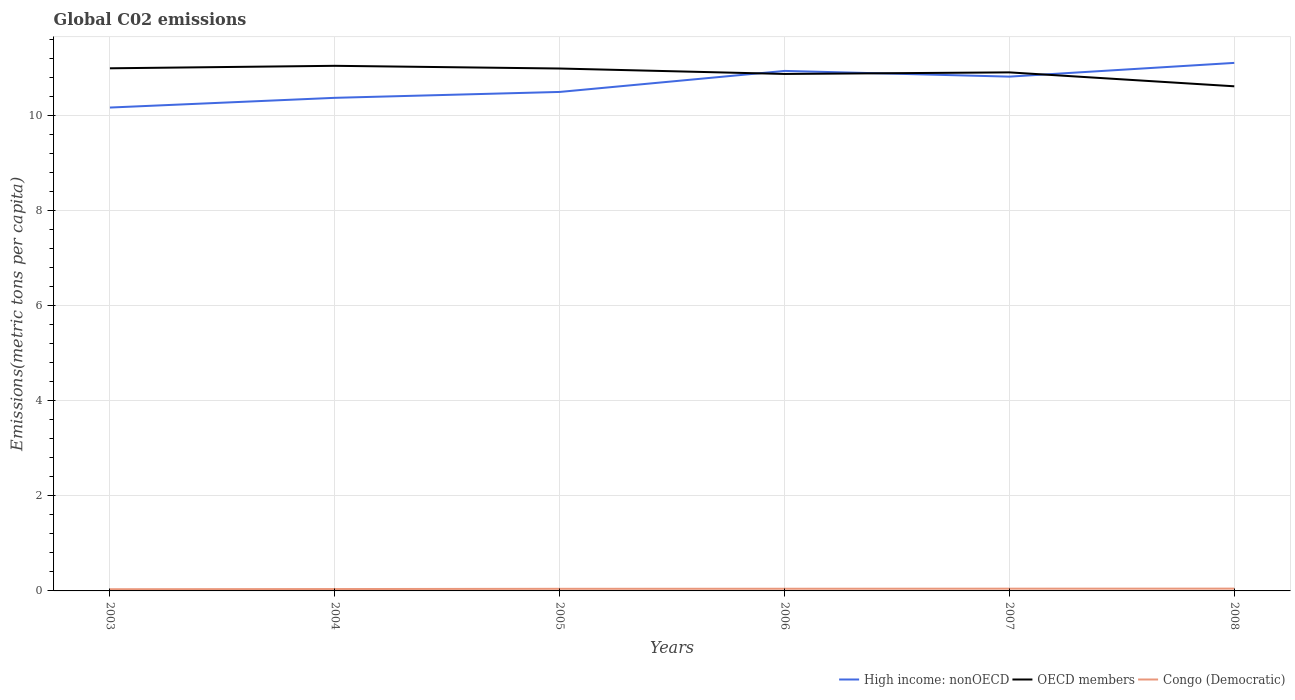Does the line corresponding to OECD members intersect with the line corresponding to High income: nonOECD?
Your answer should be compact. Yes. Across all years, what is the maximum amount of CO2 emitted in in High income: nonOECD?
Offer a very short reply. 10.17. What is the total amount of CO2 emitted in in OECD members in the graph?
Keep it short and to the point. 0.14. What is the difference between the highest and the second highest amount of CO2 emitted in in High income: nonOECD?
Your answer should be very brief. 0.94. Is the amount of CO2 emitted in in Congo (Democratic) strictly greater than the amount of CO2 emitted in in High income: nonOECD over the years?
Offer a terse response. Yes. How many lines are there?
Make the answer very short. 3. Are the values on the major ticks of Y-axis written in scientific E-notation?
Provide a succinct answer. No. Does the graph contain any zero values?
Your answer should be compact. No. Does the graph contain grids?
Ensure brevity in your answer.  Yes. Where does the legend appear in the graph?
Keep it short and to the point. Bottom right. What is the title of the graph?
Ensure brevity in your answer.  Global C02 emissions. Does "Korea (Democratic)" appear as one of the legend labels in the graph?
Ensure brevity in your answer.  No. What is the label or title of the Y-axis?
Make the answer very short. Emissions(metric tons per capita). What is the Emissions(metric tons per capita) of High income: nonOECD in 2003?
Your answer should be very brief. 10.17. What is the Emissions(metric tons per capita) of OECD members in 2003?
Provide a succinct answer. 11. What is the Emissions(metric tons per capita) in Congo (Democratic) in 2003?
Keep it short and to the point. 0.04. What is the Emissions(metric tons per capita) in High income: nonOECD in 2004?
Make the answer very short. 10.37. What is the Emissions(metric tons per capita) in OECD members in 2004?
Your answer should be very brief. 11.05. What is the Emissions(metric tons per capita) in Congo (Democratic) in 2004?
Provide a short and direct response. 0.04. What is the Emissions(metric tons per capita) of High income: nonOECD in 2005?
Ensure brevity in your answer.  10.5. What is the Emissions(metric tons per capita) of OECD members in 2005?
Your answer should be very brief. 10.99. What is the Emissions(metric tons per capita) of Congo (Democratic) in 2005?
Provide a succinct answer. 0.04. What is the Emissions(metric tons per capita) in High income: nonOECD in 2006?
Your answer should be compact. 10.94. What is the Emissions(metric tons per capita) in OECD members in 2006?
Offer a very short reply. 10.88. What is the Emissions(metric tons per capita) of Congo (Democratic) in 2006?
Your answer should be compact. 0.05. What is the Emissions(metric tons per capita) of High income: nonOECD in 2007?
Provide a short and direct response. 10.82. What is the Emissions(metric tons per capita) of OECD members in 2007?
Give a very brief answer. 10.91. What is the Emissions(metric tons per capita) in Congo (Democratic) in 2007?
Your answer should be compact. 0.05. What is the Emissions(metric tons per capita) in High income: nonOECD in 2008?
Make the answer very short. 11.11. What is the Emissions(metric tons per capita) in OECD members in 2008?
Provide a succinct answer. 10.62. What is the Emissions(metric tons per capita) in Congo (Democratic) in 2008?
Your response must be concise. 0.05. Across all years, what is the maximum Emissions(metric tons per capita) in High income: nonOECD?
Provide a short and direct response. 11.11. Across all years, what is the maximum Emissions(metric tons per capita) in OECD members?
Ensure brevity in your answer.  11.05. Across all years, what is the maximum Emissions(metric tons per capita) in Congo (Democratic)?
Offer a terse response. 0.05. Across all years, what is the minimum Emissions(metric tons per capita) of High income: nonOECD?
Your answer should be very brief. 10.17. Across all years, what is the minimum Emissions(metric tons per capita) in OECD members?
Make the answer very short. 10.62. Across all years, what is the minimum Emissions(metric tons per capita) in Congo (Democratic)?
Make the answer very short. 0.04. What is the total Emissions(metric tons per capita) in High income: nonOECD in the graph?
Provide a short and direct response. 63.92. What is the total Emissions(metric tons per capita) in OECD members in the graph?
Make the answer very short. 65.44. What is the total Emissions(metric tons per capita) of Congo (Democratic) in the graph?
Provide a succinct answer. 0.26. What is the difference between the Emissions(metric tons per capita) in High income: nonOECD in 2003 and that in 2004?
Provide a short and direct response. -0.2. What is the difference between the Emissions(metric tons per capita) of OECD members in 2003 and that in 2004?
Offer a very short reply. -0.05. What is the difference between the Emissions(metric tons per capita) of Congo (Democratic) in 2003 and that in 2004?
Give a very brief answer. -0. What is the difference between the Emissions(metric tons per capita) of High income: nonOECD in 2003 and that in 2005?
Provide a succinct answer. -0.33. What is the difference between the Emissions(metric tons per capita) of OECD members in 2003 and that in 2005?
Your answer should be compact. 0. What is the difference between the Emissions(metric tons per capita) in Congo (Democratic) in 2003 and that in 2005?
Your response must be concise. -0.01. What is the difference between the Emissions(metric tons per capita) of High income: nonOECD in 2003 and that in 2006?
Make the answer very short. -0.77. What is the difference between the Emissions(metric tons per capita) in OECD members in 2003 and that in 2006?
Your answer should be compact. 0.12. What is the difference between the Emissions(metric tons per capita) of Congo (Democratic) in 2003 and that in 2006?
Keep it short and to the point. -0.01. What is the difference between the Emissions(metric tons per capita) in High income: nonOECD in 2003 and that in 2007?
Give a very brief answer. -0.65. What is the difference between the Emissions(metric tons per capita) of OECD members in 2003 and that in 2007?
Your answer should be compact. 0.09. What is the difference between the Emissions(metric tons per capita) in Congo (Democratic) in 2003 and that in 2007?
Your response must be concise. -0.01. What is the difference between the Emissions(metric tons per capita) of High income: nonOECD in 2003 and that in 2008?
Provide a succinct answer. -0.94. What is the difference between the Emissions(metric tons per capita) in OECD members in 2003 and that in 2008?
Offer a terse response. 0.38. What is the difference between the Emissions(metric tons per capita) of Congo (Democratic) in 2003 and that in 2008?
Provide a short and direct response. -0.01. What is the difference between the Emissions(metric tons per capita) in High income: nonOECD in 2004 and that in 2005?
Your answer should be very brief. -0.12. What is the difference between the Emissions(metric tons per capita) of OECD members in 2004 and that in 2005?
Make the answer very short. 0.06. What is the difference between the Emissions(metric tons per capita) of Congo (Democratic) in 2004 and that in 2005?
Make the answer very short. -0.01. What is the difference between the Emissions(metric tons per capita) in High income: nonOECD in 2004 and that in 2006?
Your answer should be very brief. -0.57. What is the difference between the Emissions(metric tons per capita) in OECD members in 2004 and that in 2006?
Your response must be concise. 0.17. What is the difference between the Emissions(metric tons per capita) in Congo (Democratic) in 2004 and that in 2006?
Keep it short and to the point. -0.01. What is the difference between the Emissions(metric tons per capita) of High income: nonOECD in 2004 and that in 2007?
Your answer should be very brief. -0.45. What is the difference between the Emissions(metric tons per capita) in OECD members in 2004 and that in 2007?
Your answer should be very brief. 0.14. What is the difference between the Emissions(metric tons per capita) of Congo (Democratic) in 2004 and that in 2007?
Make the answer very short. -0.01. What is the difference between the Emissions(metric tons per capita) of High income: nonOECD in 2004 and that in 2008?
Provide a succinct answer. -0.73. What is the difference between the Emissions(metric tons per capita) of OECD members in 2004 and that in 2008?
Your answer should be very brief. 0.43. What is the difference between the Emissions(metric tons per capita) in Congo (Democratic) in 2004 and that in 2008?
Your response must be concise. -0.01. What is the difference between the Emissions(metric tons per capita) of High income: nonOECD in 2005 and that in 2006?
Your response must be concise. -0.44. What is the difference between the Emissions(metric tons per capita) of OECD members in 2005 and that in 2006?
Provide a succinct answer. 0.11. What is the difference between the Emissions(metric tons per capita) of Congo (Democratic) in 2005 and that in 2006?
Give a very brief answer. -0. What is the difference between the Emissions(metric tons per capita) in High income: nonOECD in 2005 and that in 2007?
Your answer should be compact. -0.32. What is the difference between the Emissions(metric tons per capita) in OECD members in 2005 and that in 2007?
Provide a succinct answer. 0.08. What is the difference between the Emissions(metric tons per capita) of Congo (Democratic) in 2005 and that in 2007?
Ensure brevity in your answer.  -0. What is the difference between the Emissions(metric tons per capita) in High income: nonOECD in 2005 and that in 2008?
Provide a short and direct response. -0.61. What is the difference between the Emissions(metric tons per capita) of OECD members in 2005 and that in 2008?
Keep it short and to the point. 0.37. What is the difference between the Emissions(metric tons per capita) in Congo (Democratic) in 2005 and that in 2008?
Provide a succinct answer. -0. What is the difference between the Emissions(metric tons per capita) in High income: nonOECD in 2006 and that in 2007?
Offer a terse response. 0.12. What is the difference between the Emissions(metric tons per capita) of OECD members in 2006 and that in 2007?
Provide a succinct answer. -0.03. What is the difference between the Emissions(metric tons per capita) in Congo (Democratic) in 2006 and that in 2007?
Ensure brevity in your answer.  -0. What is the difference between the Emissions(metric tons per capita) in High income: nonOECD in 2006 and that in 2008?
Make the answer very short. -0.17. What is the difference between the Emissions(metric tons per capita) in OECD members in 2006 and that in 2008?
Your answer should be very brief. 0.26. What is the difference between the Emissions(metric tons per capita) in Congo (Democratic) in 2006 and that in 2008?
Your response must be concise. -0. What is the difference between the Emissions(metric tons per capita) in High income: nonOECD in 2007 and that in 2008?
Your answer should be very brief. -0.29. What is the difference between the Emissions(metric tons per capita) in OECD members in 2007 and that in 2008?
Your answer should be very brief. 0.29. What is the difference between the Emissions(metric tons per capita) in Congo (Democratic) in 2007 and that in 2008?
Offer a terse response. -0. What is the difference between the Emissions(metric tons per capita) in High income: nonOECD in 2003 and the Emissions(metric tons per capita) in OECD members in 2004?
Provide a succinct answer. -0.88. What is the difference between the Emissions(metric tons per capita) in High income: nonOECD in 2003 and the Emissions(metric tons per capita) in Congo (Democratic) in 2004?
Your response must be concise. 10.13. What is the difference between the Emissions(metric tons per capita) in OECD members in 2003 and the Emissions(metric tons per capita) in Congo (Democratic) in 2004?
Make the answer very short. 10.96. What is the difference between the Emissions(metric tons per capita) of High income: nonOECD in 2003 and the Emissions(metric tons per capita) of OECD members in 2005?
Provide a short and direct response. -0.82. What is the difference between the Emissions(metric tons per capita) in High income: nonOECD in 2003 and the Emissions(metric tons per capita) in Congo (Democratic) in 2005?
Offer a very short reply. 10.13. What is the difference between the Emissions(metric tons per capita) of OECD members in 2003 and the Emissions(metric tons per capita) of Congo (Democratic) in 2005?
Keep it short and to the point. 10.95. What is the difference between the Emissions(metric tons per capita) in High income: nonOECD in 2003 and the Emissions(metric tons per capita) in OECD members in 2006?
Ensure brevity in your answer.  -0.71. What is the difference between the Emissions(metric tons per capita) in High income: nonOECD in 2003 and the Emissions(metric tons per capita) in Congo (Democratic) in 2006?
Give a very brief answer. 10.12. What is the difference between the Emissions(metric tons per capita) in OECD members in 2003 and the Emissions(metric tons per capita) in Congo (Democratic) in 2006?
Offer a terse response. 10.95. What is the difference between the Emissions(metric tons per capita) in High income: nonOECD in 2003 and the Emissions(metric tons per capita) in OECD members in 2007?
Keep it short and to the point. -0.74. What is the difference between the Emissions(metric tons per capita) of High income: nonOECD in 2003 and the Emissions(metric tons per capita) of Congo (Democratic) in 2007?
Provide a succinct answer. 10.12. What is the difference between the Emissions(metric tons per capita) in OECD members in 2003 and the Emissions(metric tons per capita) in Congo (Democratic) in 2007?
Ensure brevity in your answer.  10.95. What is the difference between the Emissions(metric tons per capita) in High income: nonOECD in 2003 and the Emissions(metric tons per capita) in OECD members in 2008?
Give a very brief answer. -0.45. What is the difference between the Emissions(metric tons per capita) in High income: nonOECD in 2003 and the Emissions(metric tons per capita) in Congo (Democratic) in 2008?
Provide a short and direct response. 10.12. What is the difference between the Emissions(metric tons per capita) in OECD members in 2003 and the Emissions(metric tons per capita) in Congo (Democratic) in 2008?
Keep it short and to the point. 10.95. What is the difference between the Emissions(metric tons per capita) of High income: nonOECD in 2004 and the Emissions(metric tons per capita) of OECD members in 2005?
Ensure brevity in your answer.  -0.62. What is the difference between the Emissions(metric tons per capita) of High income: nonOECD in 2004 and the Emissions(metric tons per capita) of Congo (Democratic) in 2005?
Your answer should be very brief. 10.33. What is the difference between the Emissions(metric tons per capita) of OECD members in 2004 and the Emissions(metric tons per capita) of Congo (Democratic) in 2005?
Give a very brief answer. 11. What is the difference between the Emissions(metric tons per capita) of High income: nonOECD in 2004 and the Emissions(metric tons per capita) of OECD members in 2006?
Offer a terse response. -0.5. What is the difference between the Emissions(metric tons per capita) in High income: nonOECD in 2004 and the Emissions(metric tons per capita) in Congo (Democratic) in 2006?
Provide a succinct answer. 10.33. What is the difference between the Emissions(metric tons per capita) of OECD members in 2004 and the Emissions(metric tons per capita) of Congo (Democratic) in 2006?
Your answer should be very brief. 11. What is the difference between the Emissions(metric tons per capita) of High income: nonOECD in 2004 and the Emissions(metric tons per capita) of OECD members in 2007?
Your answer should be very brief. -0.54. What is the difference between the Emissions(metric tons per capita) of High income: nonOECD in 2004 and the Emissions(metric tons per capita) of Congo (Democratic) in 2007?
Keep it short and to the point. 10.33. What is the difference between the Emissions(metric tons per capita) in OECD members in 2004 and the Emissions(metric tons per capita) in Congo (Democratic) in 2007?
Your answer should be very brief. 11. What is the difference between the Emissions(metric tons per capita) of High income: nonOECD in 2004 and the Emissions(metric tons per capita) of OECD members in 2008?
Offer a terse response. -0.24. What is the difference between the Emissions(metric tons per capita) in High income: nonOECD in 2004 and the Emissions(metric tons per capita) in Congo (Democratic) in 2008?
Offer a very short reply. 10.33. What is the difference between the Emissions(metric tons per capita) in High income: nonOECD in 2005 and the Emissions(metric tons per capita) in OECD members in 2006?
Ensure brevity in your answer.  -0.38. What is the difference between the Emissions(metric tons per capita) of High income: nonOECD in 2005 and the Emissions(metric tons per capita) of Congo (Democratic) in 2006?
Your response must be concise. 10.45. What is the difference between the Emissions(metric tons per capita) of OECD members in 2005 and the Emissions(metric tons per capita) of Congo (Democratic) in 2006?
Your answer should be compact. 10.95. What is the difference between the Emissions(metric tons per capita) in High income: nonOECD in 2005 and the Emissions(metric tons per capita) in OECD members in 2007?
Offer a very short reply. -0.41. What is the difference between the Emissions(metric tons per capita) in High income: nonOECD in 2005 and the Emissions(metric tons per capita) in Congo (Democratic) in 2007?
Keep it short and to the point. 10.45. What is the difference between the Emissions(metric tons per capita) of OECD members in 2005 and the Emissions(metric tons per capita) of Congo (Democratic) in 2007?
Provide a short and direct response. 10.94. What is the difference between the Emissions(metric tons per capita) of High income: nonOECD in 2005 and the Emissions(metric tons per capita) of OECD members in 2008?
Your answer should be compact. -0.12. What is the difference between the Emissions(metric tons per capita) in High income: nonOECD in 2005 and the Emissions(metric tons per capita) in Congo (Democratic) in 2008?
Keep it short and to the point. 10.45. What is the difference between the Emissions(metric tons per capita) of OECD members in 2005 and the Emissions(metric tons per capita) of Congo (Democratic) in 2008?
Offer a terse response. 10.94. What is the difference between the Emissions(metric tons per capita) of High income: nonOECD in 2006 and the Emissions(metric tons per capita) of OECD members in 2007?
Your answer should be compact. 0.03. What is the difference between the Emissions(metric tons per capita) of High income: nonOECD in 2006 and the Emissions(metric tons per capita) of Congo (Democratic) in 2007?
Offer a very short reply. 10.89. What is the difference between the Emissions(metric tons per capita) of OECD members in 2006 and the Emissions(metric tons per capita) of Congo (Democratic) in 2007?
Give a very brief answer. 10.83. What is the difference between the Emissions(metric tons per capita) of High income: nonOECD in 2006 and the Emissions(metric tons per capita) of OECD members in 2008?
Your answer should be compact. 0.32. What is the difference between the Emissions(metric tons per capita) in High income: nonOECD in 2006 and the Emissions(metric tons per capita) in Congo (Democratic) in 2008?
Provide a short and direct response. 10.89. What is the difference between the Emissions(metric tons per capita) in OECD members in 2006 and the Emissions(metric tons per capita) in Congo (Democratic) in 2008?
Ensure brevity in your answer.  10.83. What is the difference between the Emissions(metric tons per capita) of High income: nonOECD in 2007 and the Emissions(metric tons per capita) of OECD members in 2008?
Provide a short and direct response. 0.2. What is the difference between the Emissions(metric tons per capita) in High income: nonOECD in 2007 and the Emissions(metric tons per capita) in Congo (Democratic) in 2008?
Your answer should be compact. 10.77. What is the difference between the Emissions(metric tons per capita) of OECD members in 2007 and the Emissions(metric tons per capita) of Congo (Democratic) in 2008?
Provide a short and direct response. 10.86. What is the average Emissions(metric tons per capita) of High income: nonOECD per year?
Keep it short and to the point. 10.65. What is the average Emissions(metric tons per capita) of OECD members per year?
Your answer should be very brief. 10.91. What is the average Emissions(metric tons per capita) in Congo (Democratic) per year?
Offer a very short reply. 0.04. In the year 2003, what is the difference between the Emissions(metric tons per capita) of High income: nonOECD and Emissions(metric tons per capita) of OECD members?
Your response must be concise. -0.83. In the year 2003, what is the difference between the Emissions(metric tons per capita) in High income: nonOECD and Emissions(metric tons per capita) in Congo (Democratic)?
Keep it short and to the point. 10.13. In the year 2003, what is the difference between the Emissions(metric tons per capita) of OECD members and Emissions(metric tons per capita) of Congo (Democratic)?
Your answer should be compact. 10.96. In the year 2004, what is the difference between the Emissions(metric tons per capita) of High income: nonOECD and Emissions(metric tons per capita) of OECD members?
Your answer should be compact. -0.67. In the year 2004, what is the difference between the Emissions(metric tons per capita) of High income: nonOECD and Emissions(metric tons per capita) of Congo (Democratic)?
Ensure brevity in your answer.  10.34. In the year 2004, what is the difference between the Emissions(metric tons per capita) of OECD members and Emissions(metric tons per capita) of Congo (Democratic)?
Ensure brevity in your answer.  11.01. In the year 2005, what is the difference between the Emissions(metric tons per capita) of High income: nonOECD and Emissions(metric tons per capita) of OECD members?
Your answer should be very brief. -0.49. In the year 2005, what is the difference between the Emissions(metric tons per capita) of High income: nonOECD and Emissions(metric tons per capita) of Congo (Democratic)?
Your response must be concise. 10.45. In the year 2005, what is the difference between the Emissions(metric tons per capita) in OECD members and Emissions(metric tons per capita) in Congo (Democratic)?
Keep it short and to the point. 10.95. In the year 2006, what is the difference between the Emissions(metric tons per capita) of High income: nonOECD and Emissions(metric tons per capita) of OECD members?
Provide a succinct answer. 0.06. In the year 2006, what is the difference between the Emissions(metric tons per capita) in High income: nonOECD and Emissions(metric tons per capita) in Congo (Democratic)?
Give a very brief answer. 10.9. In the year 2006, what is the difference between the Emissions(metric tons per capita) of OECD members and Emissions(metric tons per capita) of Congo (Democratic)?
Offer a very short reply. 10.83. In the year 2007, what is the difference between the Emissions(metric tons per capita) of High income: nonOECD and Emissions(metric tons per capita) of OECD members?
Offer a very short reply. -0.09. In the year 2007, what is the difference between the Emissions(metric tons per capita) of High income: nonOECD and Emissions(metric tons per capita) of Congo (Democratic)?
Provide a short and direct response. 10.77. In the year 2007, what is the difference between the Emissions(metric tons per capita) of OECD members and Emissions(metric tons per capita) of Congo (Democratic)?
Make the answer very short. 10.86. In the year 2008, what is the difference between the Emissions(metric tons per capita) in High income: nonOECD and Emissions(metric tons per capita) in OECD members?
Offer a very short reply. 0.49. In the year 2008, what is the difference between the Emissions(metric tons per capita) in High income: nonOECD and Emissions(metric tons per capita) in Congo (Democratic)?
Your answer should be compact. 11.06. In the year 2008, what is the difference between the Emissions(metric tons per capita) of OECD members and Emissions(metric tons per capita) of Congo (Democratic)?
Make the answer very short. 10.57. What is the ratio of the Emissions(metric tons per capita) in High income: nonOECD in 2003 to that in 2004?
Your answer should be compact. 0.98. What is the ratio of the Emissions(metric tons per capita) in Congo (Democratic) in 2003 to that in 2004?
Your response must be concise. 0.9. What is the ratio of the Emissions(metric tons per capita) of High income: nonOECD in 2003 to that in 2005?
Provide a succinct answer. 0.97. What is the ratio of the Emissions(metric tons per capita) of OECD members in 2003 to that in 2005?
Provide a succinct answer. 1. What is the ratio of the Emissions(metric tons per capita) of Congo (Democratic) in 2003 to that in 2005?
Provide a short and direct response. 0.8. What is the ratio of the Emissions(metric tons per capita) of High income: nonOECD in 2003 to that in 2006?
Your answer should be compact. 0.93. What is the ratio of the Emissions(metric tons per capita) of Congo (Democratic) in 2003 to that in 2006?
Give a very brief answer. 0.78. What is the ratio of the Emissions(metric tons per capita) of High income: nonOECD in 2003 to that in 2007?
Your answer should be compact. 0.94. What is the ratio of the Emissions(metric tons per capita) of OECD members in 2003 to that in 2007?
Provide a succinct answer. 1.01. What is the ratio of the Emissions(metric tons per capita) of Congo (Democratic) in 2003 to that in 2007?
Ensure brevity in your answer.  0.75. What is the ratio of the Emissions(metric tons per capita) in High income: nonOECD in 2003 to that in 2008?
Offer a very short reply. 0.92. What is the ratio of the Emissions(metric tons per capita) in OECD members in 2003 to that in 2008?
Provide a succinct answer. 1.04. What is the ratio of the Emissions(metric tons per capita) in Congo (Democratic) in 2003 to that in 2008?
Offer a terse response. 0.73. What is the ratio of the Emissions(metric tons per capita) of OECD members in 2004 to that in 2005?
Ensure brevity in your answer.  1.01. What is the ratio of the Emissions(metric tons per capita) in Congo (Democratic) in 2004 to that in 2005?
Offer a terse response. 0.89. What is the ratio of the Emissions(metric tons per capita) of High income: nonOECD in 2004 to that in 2006?
Your answer should be compact. 0.95. What is the ratio of the Emissions(metric tons per capita) of OECD members in 2004 to that in 2006?
Provide a succinct answer. 1.02. What is the ratio of the Emissions(metric tons per capita) of Congo (Democratic) in 2004 to that in 2006?
Provide a short and direct response. 0.86. What is the ratio of the Emissions(metric tons per capita) of High income: nonOECD in 2004 to that in 2007?
Give a very brief answer. 0.96. What is the ratio of the Emissions(metric tons per capita) in OECD members in 2004 to that in 2007?
Your response must be concise. 1.01. What is the ratio of the Emissions(metric tons per capita) of Congo (Democratic) in 2004 to that in 2007?
Your answer should be very brief. 0.83. What is the ratio of the Emissions(metric tons per capita) in High income: nonOECD in 2004 to that in 2008?
Give a very brief answer. 0.93. What is the ratio of the Emissions(metric tons per capita) of OECD members in 2004 to that in 2008?
Your response must be concise. 1.04. What is the ratio of the Emissions(metric tons per capita) in Congo (Democratic) in 2004 to that in 2008?
Your answer should be compact. 0.81. What is the ratio of the Emissions(metric tons per capita) in High income: nonOECD in 2005 to that in 2006?
Your answer should be compact. 0.96. What is the ratio of the Emissions(metric tons per capita) in OECD members in 2005 to that in 2006?
Keep it short and to the point. 1.01. What is the ratio of the Emissions(metric tons per capita) in Congo (Democratic) in 2005 to that in 2006?
Ensure brevity in your answer.  0.97. What is the ratio of the Emissions(metric tons per capita) in High income: nonOECD in 2005 to that in 2007?
Offer a very short reply. 0.97. What is the ratio of the Emissions(metric tons per capita) of OECD members in 2005 to that in 2007?
Your answer should be compact. 1.01. What is the ratio of the Emissions(metric tons per capita) in Congo (Democratic) in 2005 to that in 2007?
Give a very brief answer. 0.94. What is the ratio of the Emissions(metric tons per capita) in High income: nonOECD in 2005 to that in 2008?
Ensure brevity in your answer.  0.94. What is the ratio of the Emissions(metric tons per capita) of OECD members in 2005 to that in 2008?
Give a very brief answer. 1.04. What is the ratio of the Emissions(metric tons per capita) of Congo (Democratic) in 2005 to that in 2008?
Your response must be concise. 0.92. What is the ratio of the Emissions(metric tons per capita) of High income: nonOECD in 2006 to that in 2007?
Your answer should be very brief. 1.01. What is the ratio of the Emissions(metric tons per capita) of Congo (Democratic) in 2006 to that in 2007?
Provide a short and direct response. 0.96. What is the ratio of the Emissions(metric tons per capita) in OECD members in 2006 to that in 2008?
Offer a terse response. 1.02. What is the ratio of the Emissions(metric tons per capita) in Congo (Democratic) in 2006 to that in 2008?
Ensure brevity in your answer.  0.94. What is the ratio of the Emissions(metric tons per capita) in High income: nonOECD in 2007 to that in 2008?
Keep it short and to the point. 0.97. What is the ratio of the Emissions(metric tons per capita) of OECD members in 2007 to that in 2008?
Make the answer very short. 1.03. What is the ratio of the Emissions(metric tons per capita) in Congo (Democratic) in 2007 to that in 2008?
Keep it short and to the point. 0.98. What is the difference between the highest and the second highest Emissions(metric tons per capita) in High income: nonOECD?
Your answer should be very brief. 0.17. What is the difference between the highest and the second highest Emissions(metric tons per capita) in OECD members?
Give a very brief answer. 0.05. What is the difference between the highest and the second highest Emissions(metric tons per capita) in Congo (Democratic)?
Provide a short and direct response. 0. What is the difference between the highest and the lowest Emissions(metric tons per capita) in High income: nonOECD?
Ensure brevity in your answer.  0.94. What is the difference between the highest and the lowest Emissions(metric tons per capita) of OECD members?
Your answer should be very brief. 0.43. What is the difference between the highest and the lowest Emissions(metric tons per capita) in Congo (Democratic)?
Keep it short and to the point. 0.01. 